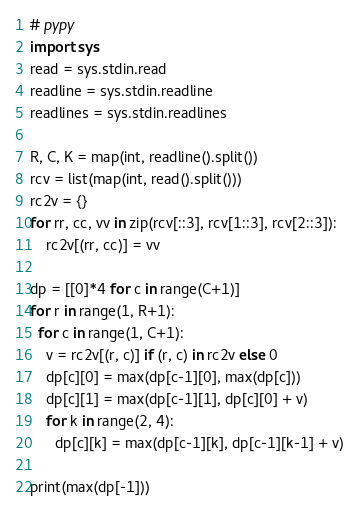Convert code to text. <code><loc_0><loc_0><loc_500><loc_500><_Python_># pypy
import sys
read = sys.stdin.read
readline = sys.stdin.readline
readlines = sys.stdin.readlines

R, C, K = map(int, readline().split())
rcv = list(map(int, read().split()))
rc2v = {}
for rr, cc, vv in zip(rcv[::3], rcv[1::3], rcv[2::3]):
    rc2v[(rr, cc)] = vv

dp = [[0]*4 for c in range(C+1)]
for r in range(1, R+1):
  for c in range(1, C+1):
    v = rc2v[(r, c)] if (r, c) in rc2v else 0
    dp[c][0] = max(dp[c-1][0], max(dp[c]))
    dp[c][1] = max(dp[c-1][1], dp[c][0] + v)
    for k in range(2, 4):
      dp[c][k] = max(dp[c-1][k], dp[c-1][k-1] + v)

print(max(dp[-1]))</code> 